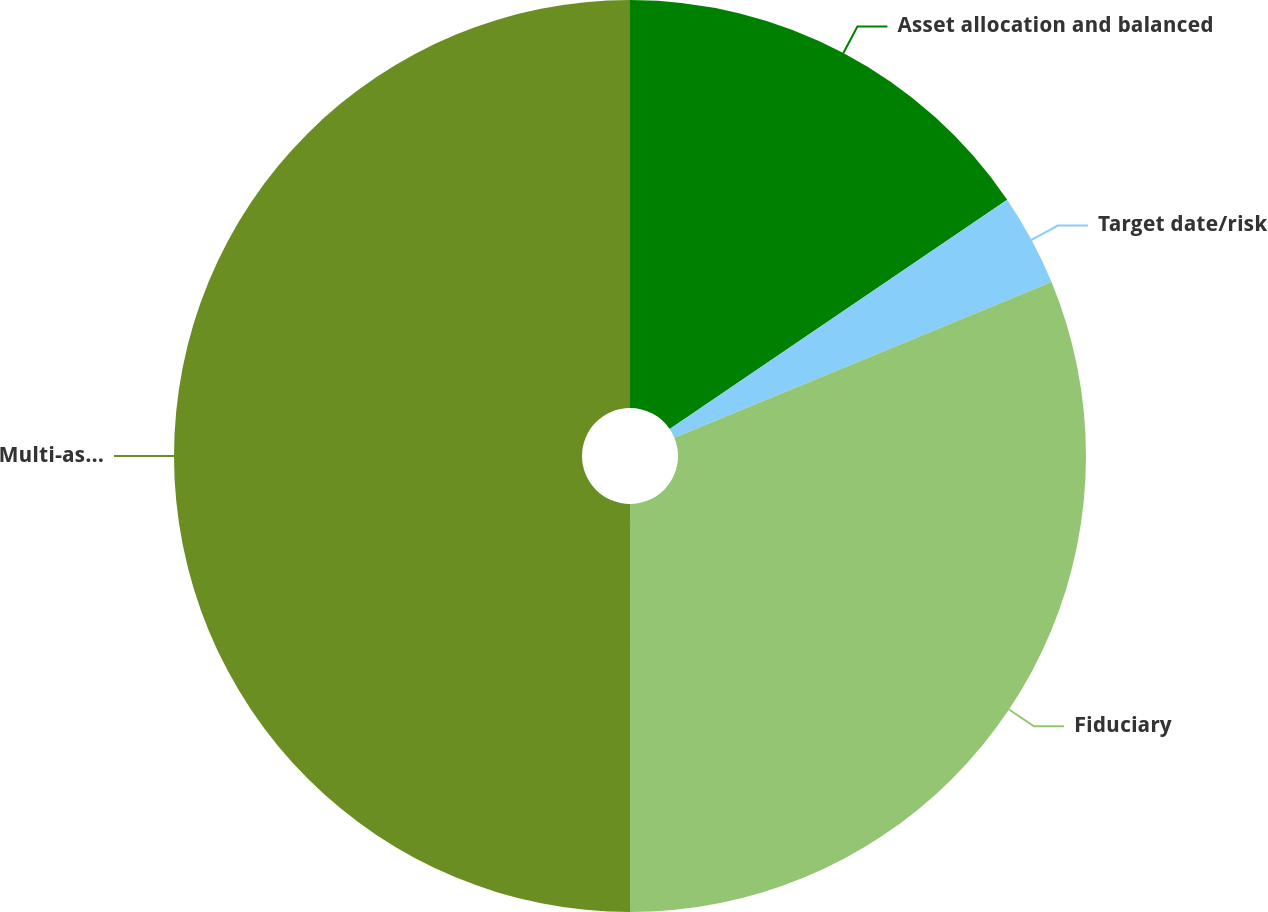<chart> <loc_0><loc_0><loc_500><loc_500><pie_chart><fcel>Asset allocation and balanced<fcel>Target date/risk<fcel>Fiduciary<fcel>Multi-asset<nl><fcel>15.5%<fcel>3.27%<fcel>31.22%<fcel>50.0%<nl></chart> 